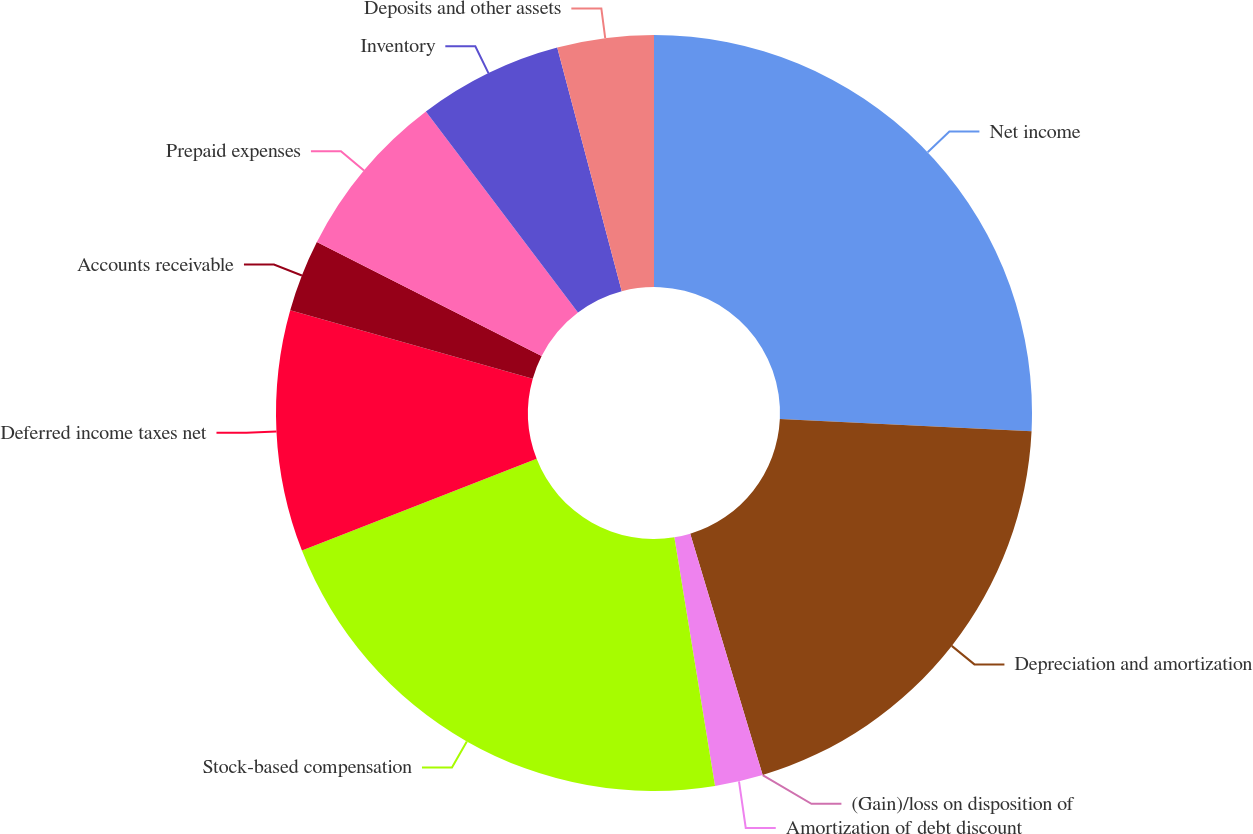Convert chart to OTSL. <chart><loc_0><loc_0><loc_500><loc_500><pie_chart><fcel>Net income<fcel>Depreciation and amortization<fcel>(Gain)/loss on disposition of<fcel>Amortization of debt discount<fcel>Stock-based compensation<fcel>Deferred income taxes net<fcel>Accounts receivable<fcel>Prepaid expenses<fcel>Inventory<fcel>Deposits and other assets<nl><fcel>25.77%<fcel>19.59%<fcel>0.0%<fcel>2.06%<fcel>21.65%<fcel>10.31%<fcel>3.09%<fcel>7.22%<fcel>6.19%<fcel>4.12%<nl></chart> 